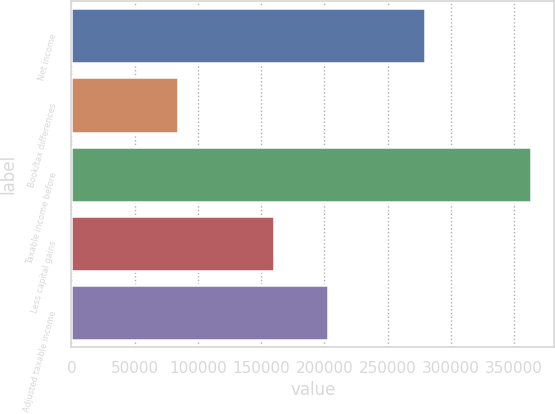Convert chart. <chart><loc_0><loc_0><loc_500><loc_500><bar_chart><fcel>Net income<fcel>Book/tax differences<fcel>Taxable income before<fcel>Less capital gains<fcel>Adjusted taxable income<nl><fcel>279467<fcel>84120<fcel>363587<fcel>160428<fcel>203159<nl></chart> 